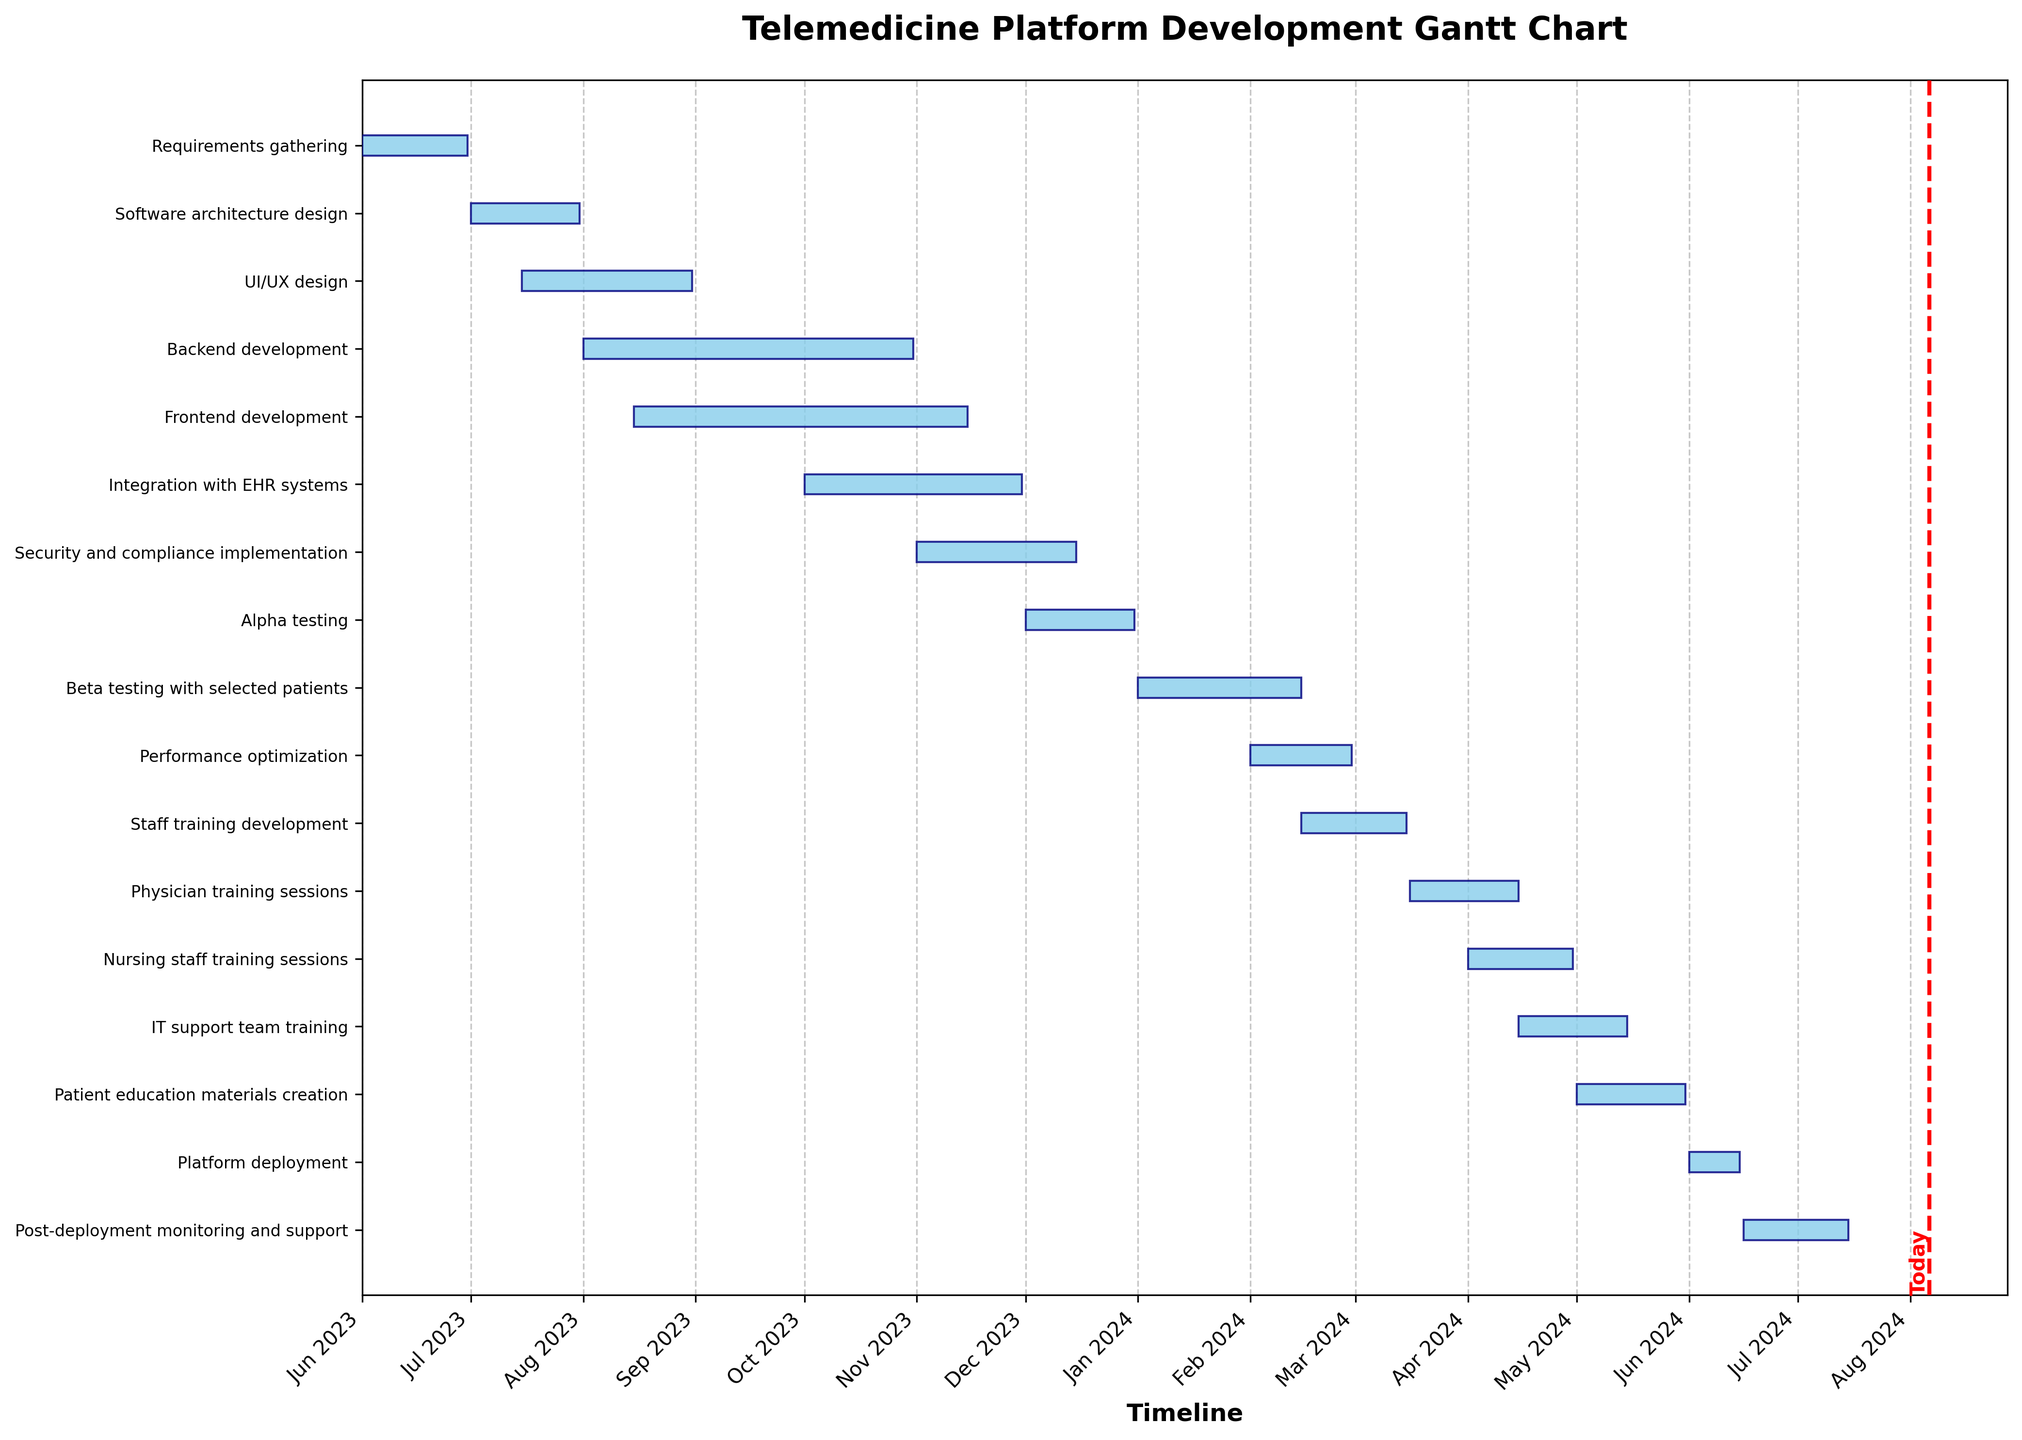What's the title of the figure? The title is usually located at the top of the figure and describes the content or purpose of the chart. Here, the title is visible as "Telemedicine Platform Development Gantt Chart".
Answer: Telemedicine Platform Development Gantt Chart What is the color of the bars representing the tasks? The color of the bars can be identified by examining the visual attributes of the bars on the Gantt Chart. All task bars are colored in "skyblue" with a "navy" edge.
Answer: Skyblue When does the "Backend development" task start and end? To find the start and end dates of "Backend development", locate this task on the y-axis and follow the horizontal bar to find its position on the timeline. According to the chart, it starts on August 1, 2023, and ends on October 31, 2023.
Answer: August 1, 2023, to October 31, 2023 Which phase overlaps with "Alpha testing"? To determine overlapping tasks, find "Alpha testing" on the y-axis and look for any other bars that intersect the same horizontal range (December 2023). The "Security and compliance implementation" phase overlaps with "Alpha testing".
Answer: Security and compliance implementation How many tasks are planned to be completed by the end of 2023? To get this, count the number of tasks with end dates in 2023 by looking at the end of each horizontal bar up to December 2023. There are 7 tasks: "Requirements gathering", "Software architecture design", "UI/UX design", "Backend development", "Frontend development", "Integration with EHR systems", and "Security and compliance implementation".
Answer: 7 Which task has the longest duration, and what is it? The longest task duration can be found by comparing the length of the horizontal bars. The "Frontend development" has the longest duration with 93 days.
Answer: Frontend development, 93 days Which two tasks start in February 2024? To identify tasks starting in February 2024, locate the start points of bars within that month. Both "Performance optimization" and "Staff training development" start in February 2024.
Answer: Performance optimization and Staff training development Are there any tasks that continue beyond May 2024? To find tasks continuing beyond May 2024, check for any bars that extend past this point on the timeline. Tasks that extend beyond May 2024 include "Platform deployment" and "Post-deployment monitoring and support".
Answer: Platform deployment and Post-deployment monitoring and support What is the duration difference between "Physician training sessions" and "Nursing staff training sessions"? To find the duration difference, subtract the duration of "Nursing staff training sessions" (30 days) from the duration of "Physician training sessions" (31 days). The difference is 1 day.
Answer: 1 day 